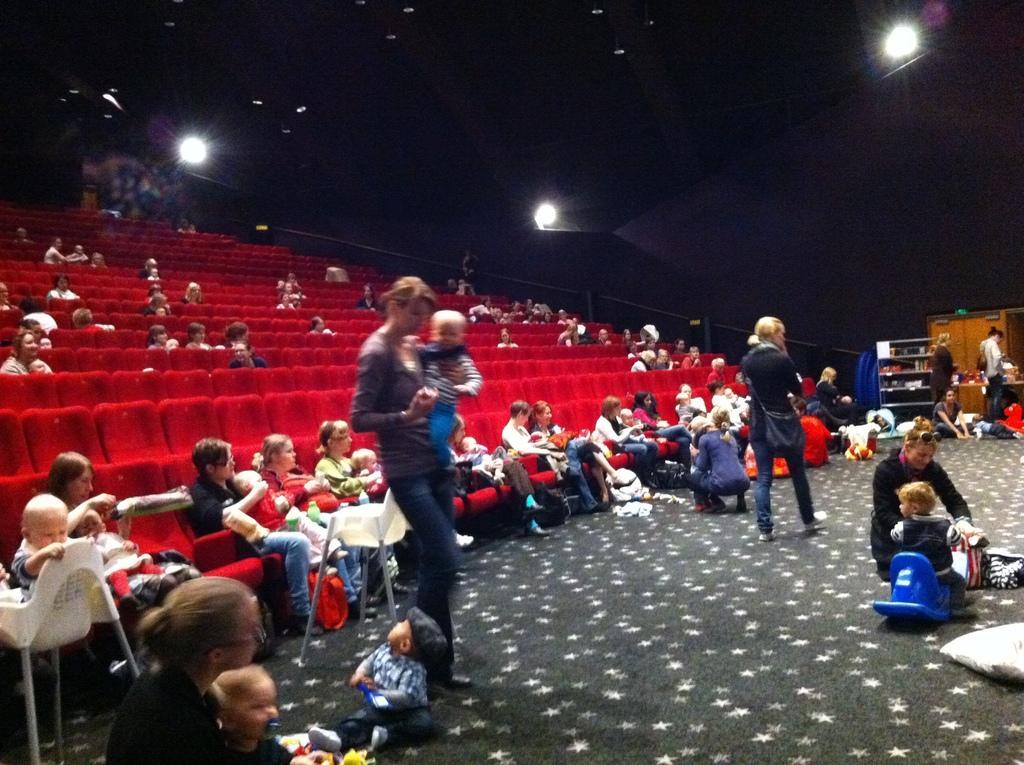Please provide a concise description of this image. In this image I can see in the middle a woman is holding the baby, on the right side a baby is playing with the blue color toy. On the left side few people are sitting red color chairs, at the top there are lights. 